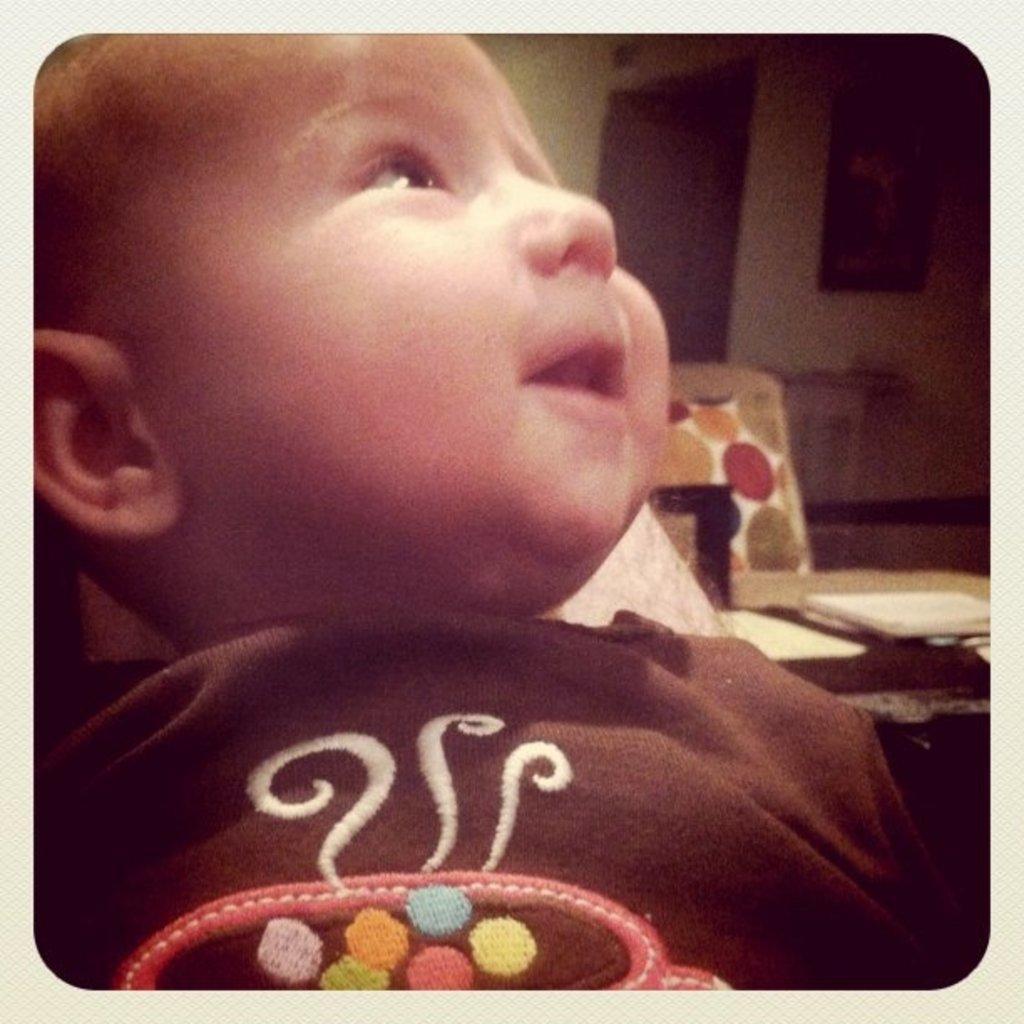In one or two sentences, can you explain what this image depicts? In this image in the foreground there is one baby, and in the background there is a chair, table. On the table there are some papers, wall, photo frame, door and some objects. 